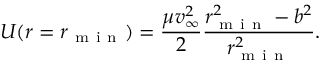Convert formula to latex. <formula><loc_0><loc_0><loc_500><loc_500>U ( r = r _ { m i n } ) = \frac { \mu v _ { \infty } ^ { 2 } } { 2 } \frac { r _ { m i n } ^ { 2 } - b ^ { 2 } } { r _ { m i n } ^ { 2 } } .</formula> 